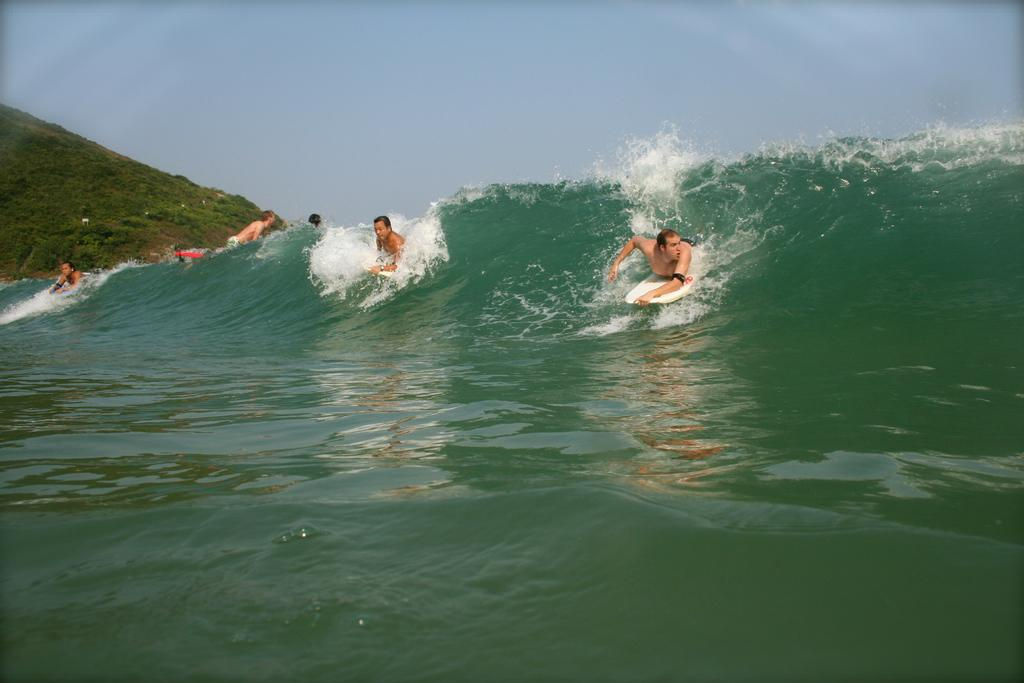What are the people in the image doing? The people in the image are lying on surfboards. Where are the surfboards located? The surfboards are on the water. What can be seen on the left side of the image? There is a hill on the left side of the image. What is visible behind the hill? The sky is visible behind the hill. How is the hill being washed in the image? The hill is not being washed in the image; there is no indication of any washing activity. 